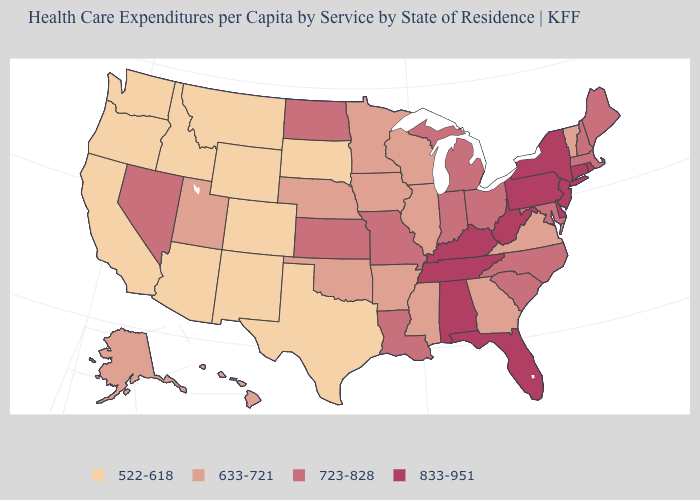How many symbols are there in the legend?
Concise answer only. 4. Name the states that have a value in the range 522-618?
Be succinct. Arizona, California, Colorado, Idaho, Montana, New Mexico, Oregon, South Dakota, Texas, Washington, Wyoming. Is the legend a continuous bar?
Concise answer only. No. What is the value of Michigan?
Be succinct. 723-828. Among the states that border Georgia , which have the lowest value?
Quick response, please. North Carolina, South Carolina. Among the states that border Idaho , which have the lowest value?
Keep it brief. Montana, Oregon, Washington, Wyoming. Which states have the highest value in the USA?
Short answer required. Alabama, Connecticut, Delaware, Florida, Kentucky, New Jersey, New York, Pennsylvania, Rhode Island, Tennessee, West Virginia. What is the value of Wisconsin?
Keep it brief. 633-721. Name the states that have a value in the range 633-721?
Short answer required. Alaska, Arkansas, Georgia, Hawaii, Illinois, Iowa, Minnesota, Mississippi, Nebraska, Oklahoma, Utah, Vermont, Virginia, Wisconsin. What is the value of South Dakota?
Concise answer only. 522-618. Does Nevada have a higher value than North Dakota?
Give a very brief answer. No. Among the states that border Utah , does Nevada have the lowest value?
Short answer required. No. Does Pennsylvania have a higher value than New Hampshire?
Answer briefly. Yes. Does South Dakota have a higher value than Idaho?
Write a very short answer. No. What is the value of Wyoming?
Answer briefly. 522-618. 